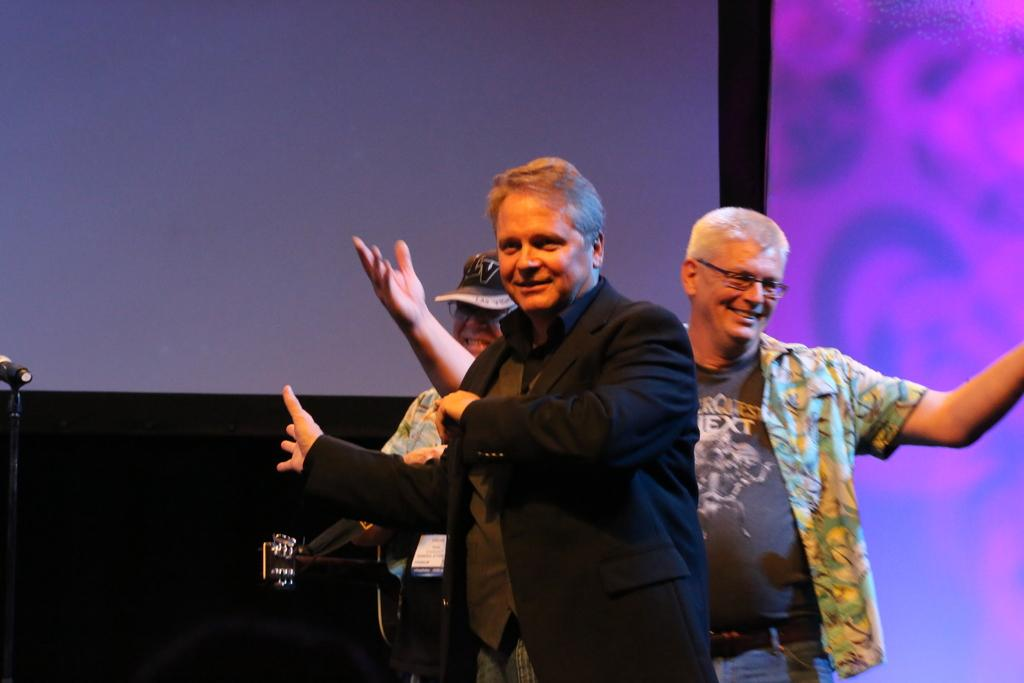How many people are in the image? There are three persons in the image. What is one of the persons doing in the image? One of the persons is playing a guitar. What object is present in the image that is commonly used for amplifying sound? There is a microphone (mike) in the image. What can be seen in the background of the image? There is a screen in the background of the image. Can you see any ducks or cabbages in the image? No, there are no ducks or cabbages present in the image. Is there a brush visible in the image? No, there is no brush visible in the image. 